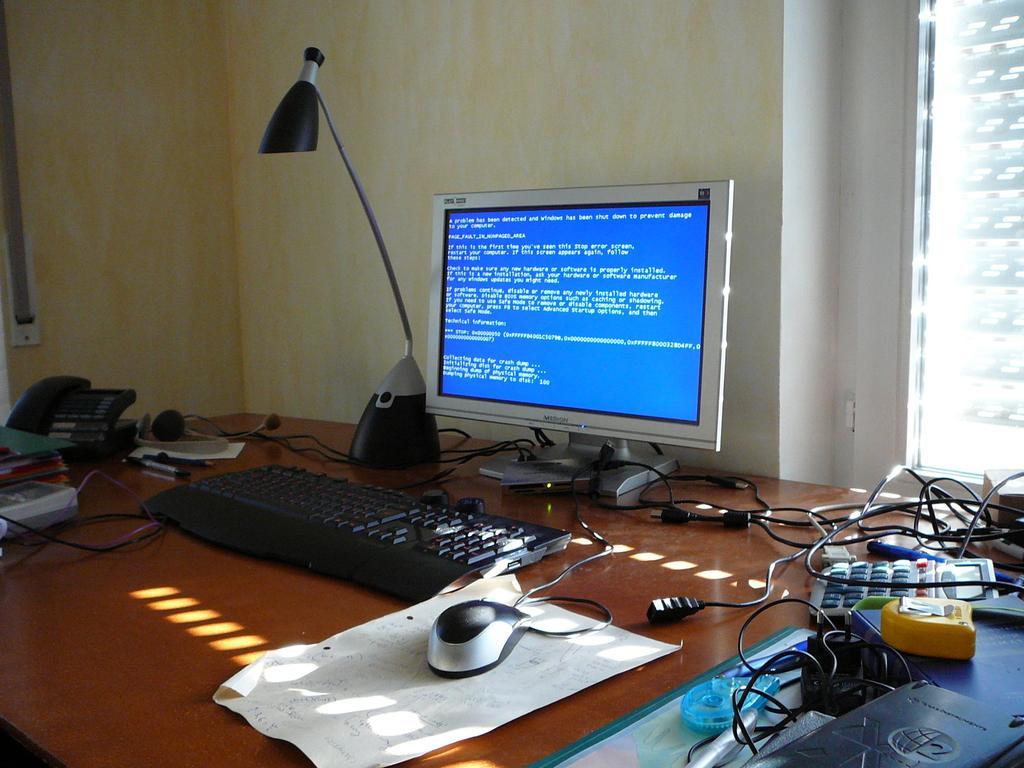Can you describe this image briefly? In this image there is a table. On this table there is a monitor, lamp, a keyboard, a mouse. This mouse is placed over a paper. On this table other there are objects also like telephone, tape, calculator, pens, books and cables. On the top left there is a window. On the left we can see a stapler and headphones. 